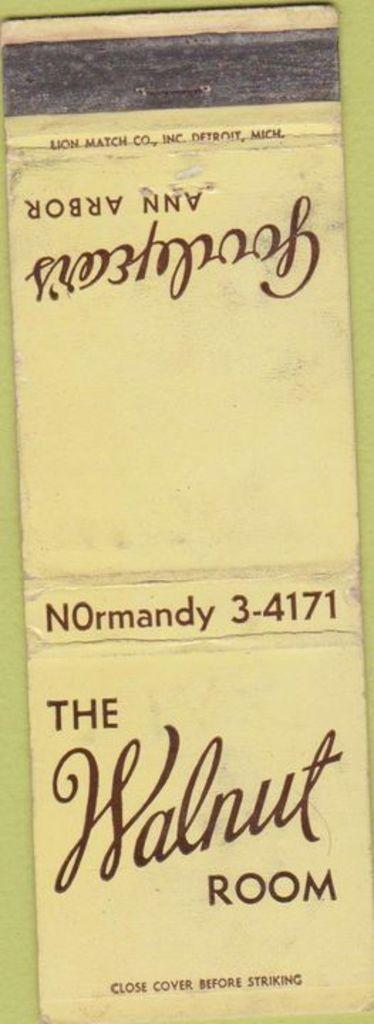<image>
Give a short and clear explanation of the subsequent image. a book that says The Walnut Room on the side of it' 